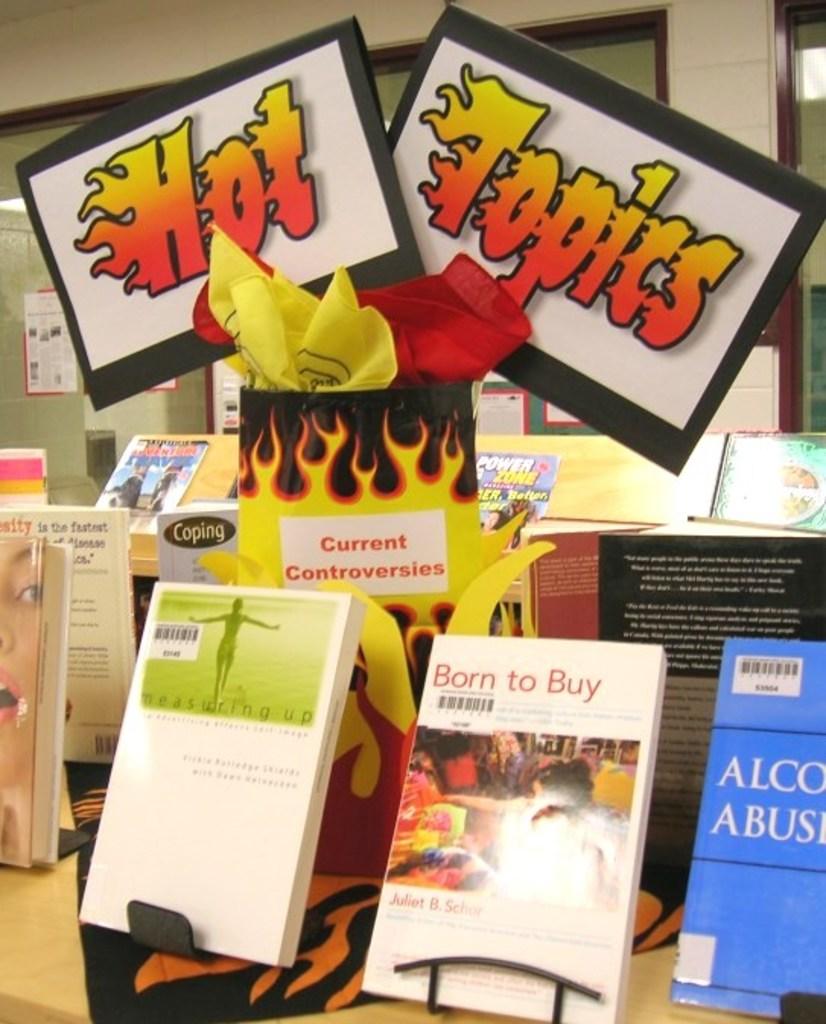What is the title to the white book on the left side of the blue book?
Your answer should be compact. Born to buy. 